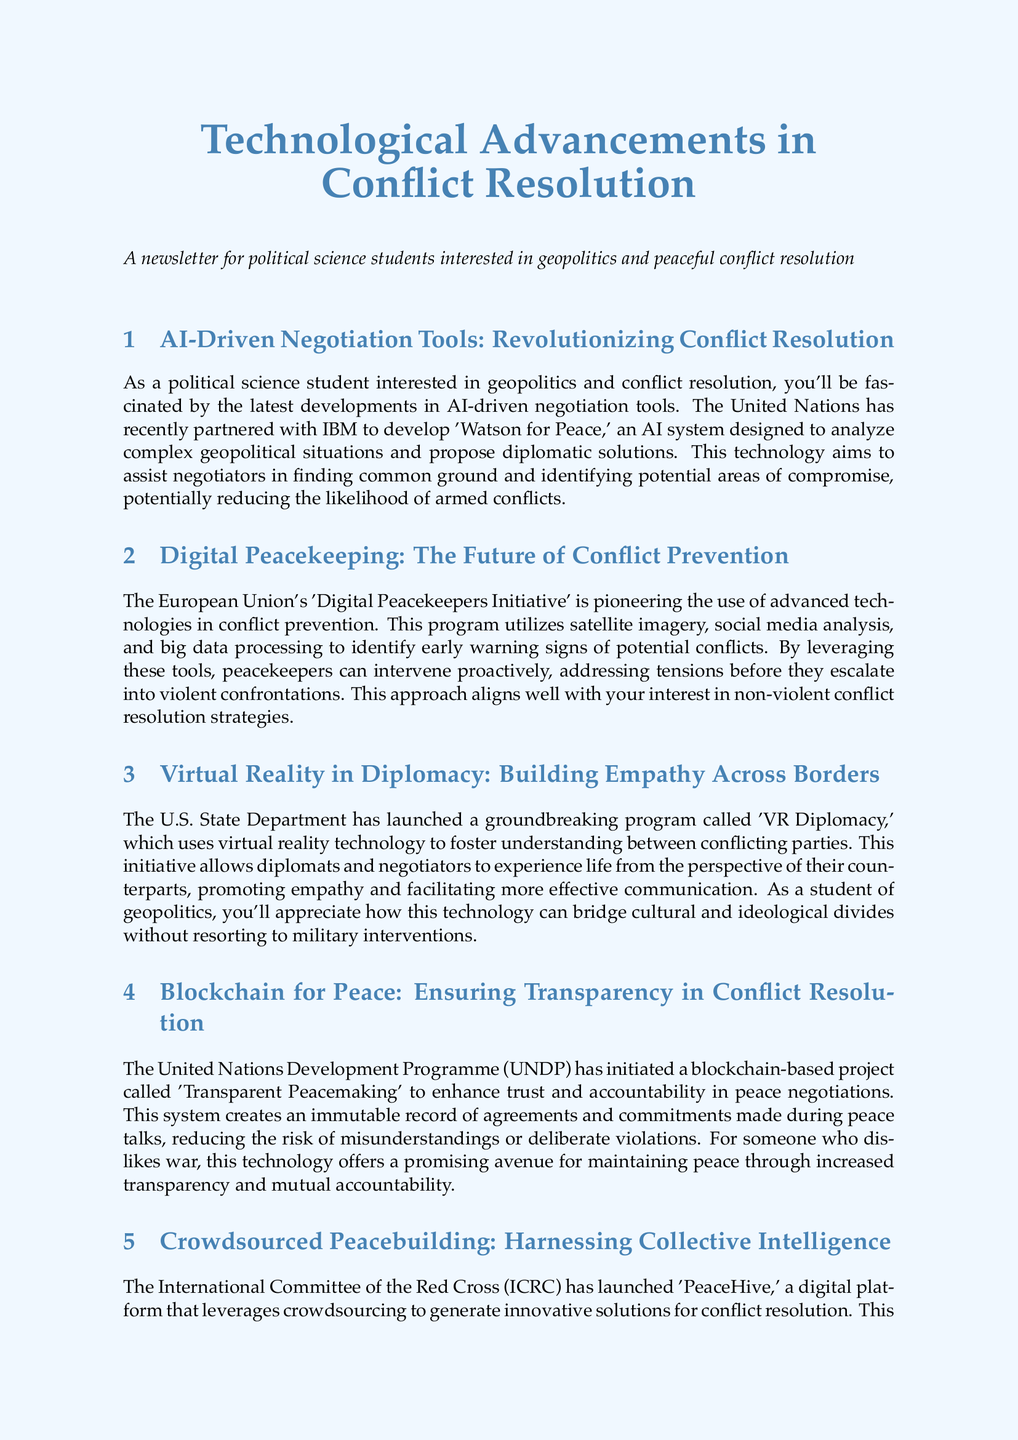What is the name of the AI system developed by IBM for the UN? The document mentions 'Watson for Peace' as the AI system designed for the UN.
Answer: Watson for Peace What initiative uses satellite imagery to identify early warning signs of potential conflicts? The document refers to the 'Digital Peacekeepers Initiative' as utilizing satellite imagery for conflict prevention.
Answer: Digital Peacekeepers Initiative Which program allows diplomats to experience life from their counterparts' perspectives? The document describes 'VR Diplomacy' as the program using virtual reality for fostering understanding between conflicting parties.
Answer: VR Diplomacy What is the title of the blockchain project initiated by the UNDP? The document states that the blockchain project initiated by the UNDP is called 'Transparent Peacemaking'.
Answer: Transparent Peacemaking What is the purpose of the PeaceHive platform? The document indicates that PeaceHive leverages crowdsourcing to generate innovative solutions for conflict resolution.
Answer: Generate innovative solutions Which organization offers a free online course on technology in conflict resolution? The document mentions the United States Institute of Peace offering the course.
Answer: United States Institute of Peace What type of analysis does the book 'Bits and Atoms' provide? The document describes the book as providing an in-depth analysis of how digital technologies are reshaping governance and conflict resolution.
Answer: In-depth analysis What is the focus of the podcast 'Digital Peace Talks'? The document specifies that the podcast features interviews with experts on the intersection of technology and conflict resolution.
Answer: Technology and conflict resolution What does the AI-driven negotiation tool aim to reduce? The document states that the goal is to reduce the likelihood of armed conflicts.
Answer: Likelihood of armed conflicts 